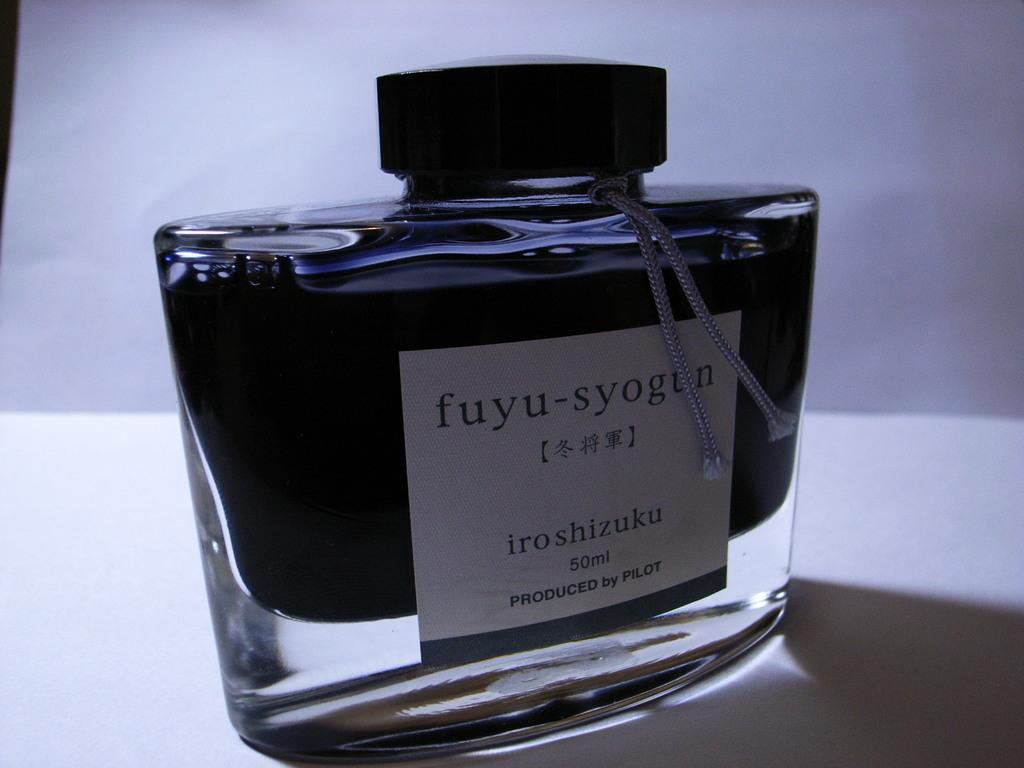<image>
Write a terse but informative summary of the picture. Bottle of cologne titled Fuyu-Syogun on top of a table. 